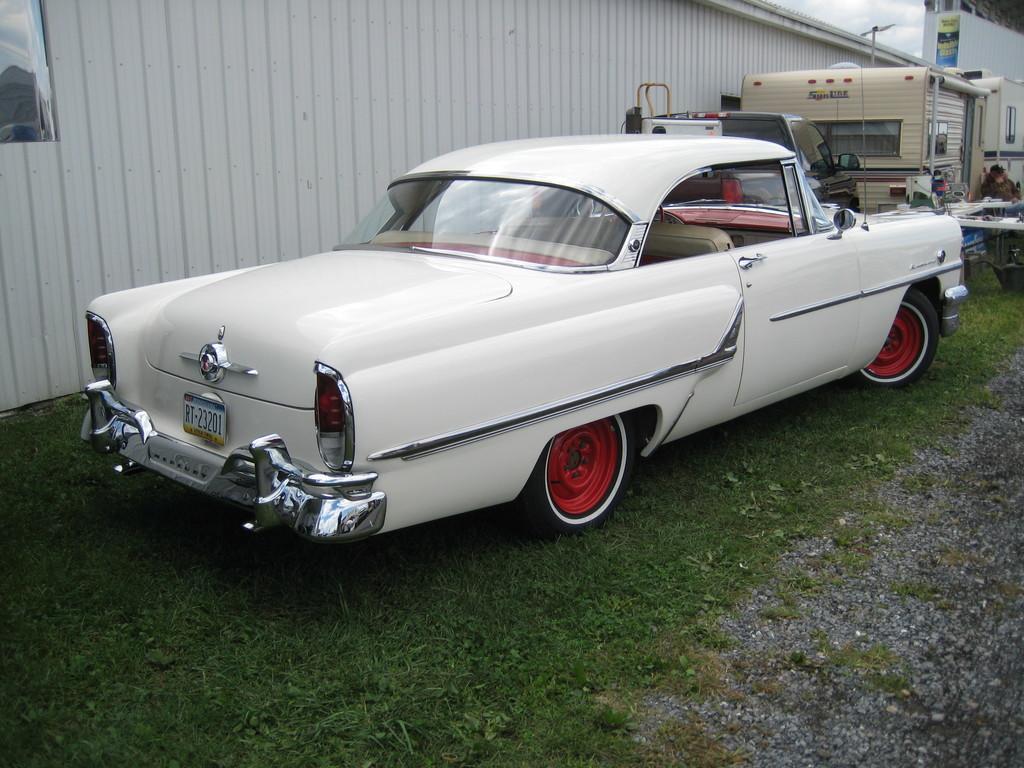Could you give a brief overview of what you see in this image? In this image there is a vehicle parked on the surface of the grass. On the right side of the image there is a person and there are some other objects. In the background there is a shed with metal. 